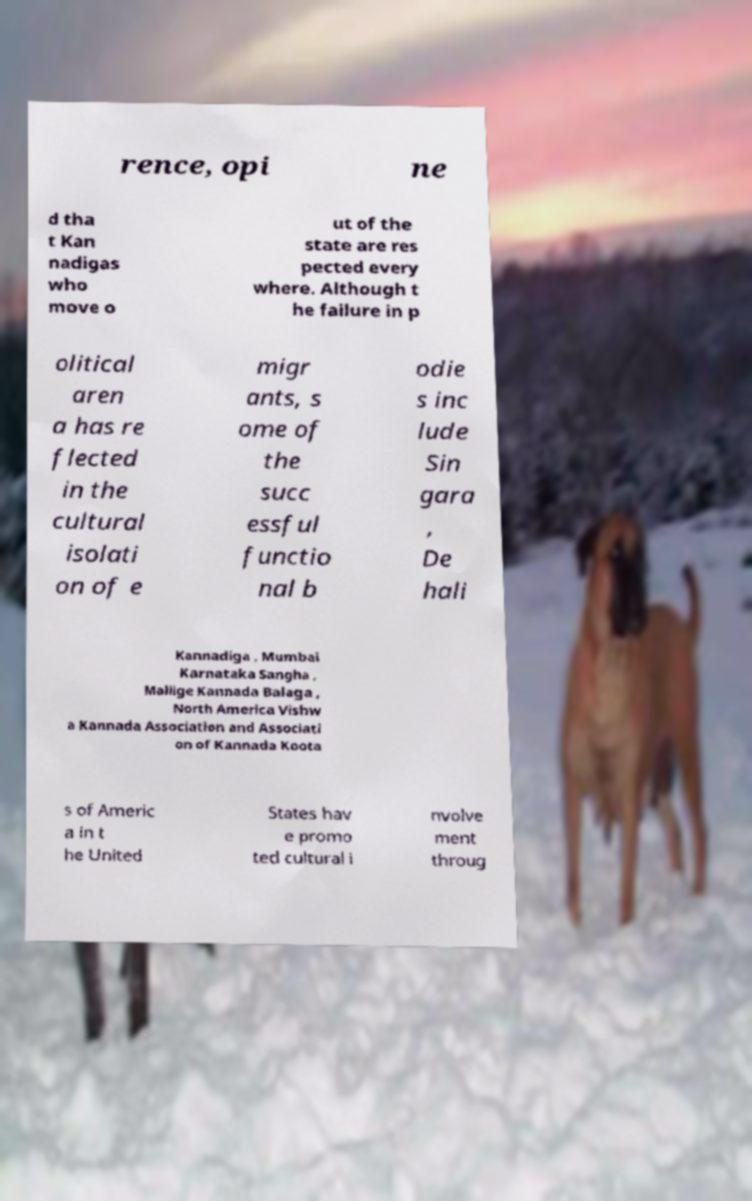Could you extract and type out the text from this image? rence, opi ne d tha t Kan nadigas who move o ut of the state are res pected every where. Although t he failure in p olitical aren a has re flected in the cultural isolati on of e migr ants, s ome of the succ essful functio nal b odie s inc lude Sin gara , De hali Kannadiga , Mumbai Karnataka Sangha , Mallige Kannada Balaga , North America Vishw a Kannada Association and Associati on of Kannada Koota s of Americ a in t he United States hav e promo ted cultural i nvolve ment throug 